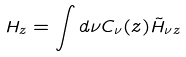<formula> <loc_0><loc_0><loc_500><loc_500>H _ { z } = \int d \nu C _ { \nu } ( z ) \tilde { H } _ { \nu z }</formula> 